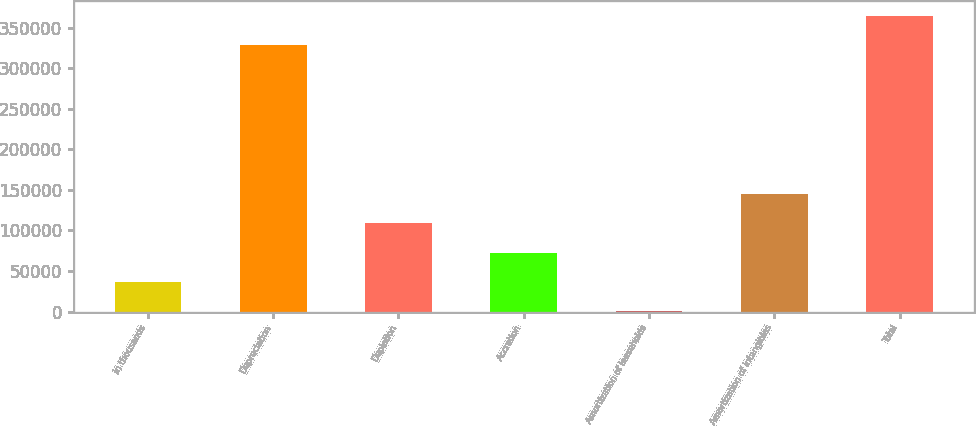<chart> <loc_0><loc_0><loc_500><loc_500><bar_chart><fcel>in thousands<fcel>Depreciation<fcel>Depletion<fcel>Accretion<fcel>Amortization of leaseholds<fcel>Amortization of intangibles<fcel>Total<nl><fcel>36374.4<fcel>328072<fcel>108673<fcel>72523.8<fcel>225<fcel>144823<fcel>364221<nl></chart> 